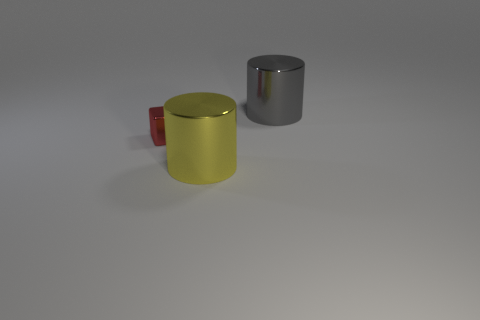Is the gray metal thing the same size as the yellow thing? While the gray metal cylinder and the yellow cylinder appear similar in height, the diameters are not clearly visible from this angle, so it's not possible to confirm if they are exactly the same size based solely on this image. 